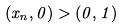Convert formula to latex. <formula><loc_0><loc_0><loc_500><loc_500>( x _ { n } , 0 ) > ( 0 , 1 )</formula> 